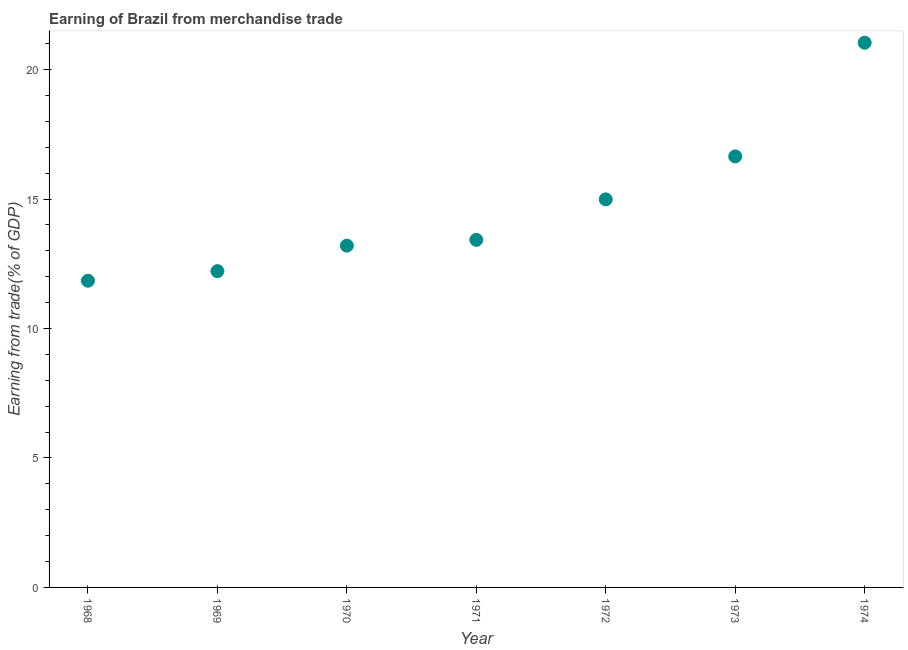What is the earning from merchandise trade in 1970?
Make the answer very short. 13.2. Across all years, what is the maximum earning from merchandise trade?
Your answer should be very brief. 21.04. Across all years, what is the minimum earning from merchandise trade?
Keep it short and to the point. 11.85. In which year was the earning from merchandise trade maximum?
Provide a short and direct response. 1974. In which year was the earning from merchandise trade minimum?
Your answer should be compact. 1968. What is the sum of the earning from merchandise trade?
Make the answer very short. 103.36. What is the difference between the earning from merchandise trade in 1970 and 1973?
Offer a terse response. -3.45. What is the average earning from merchandise trade per year?
Your answer should be very brief. 14.77. What is the median earning from merchandise trade?
Offer a terse response. 13.42. In how many years, is the earning from merchandise trade greater than 19 %?
Make the answer very short. 1. What is the ratio of the earning from merchandise trade in 1972 to that in 1973?
Your answer should be very brief. 0.9. Is the earning from merchandise trade in 1971 less than that in 1974?
Provide a succinct answer. Yes. Is the difference between the earning from merchandise trade in 1969 and 1973 greater than the difference between any two years?
Make the answer very short. No. What is the difference between the highest and the second highest earning from merchandise trade?
Your answer should be compact. 4.39. What is the difference between the highest and the lowest earning from merchandise trade?
Your response must be concise. 9.19. What is the title of the graph?
Make the answer very short. Earning of Brazil from merchandise trade. What is the label or title of the X-axis?
Ensure brevity in your answer.  Year. What is the label or title of the Y-axis?
Your answer should be compact. Earning from trade(% of GDP). What is the Earning from trade(% of GDP) in 1968?
Provide a short and direct response. 11.85. What is the Earning from trade(% of GDP) in 1969?
Your answer should be compact. 12.22. What is the Earning from trade(% of GDP) in 1970?
Provide a succinct answer. 13.2. What is the Earning from trade(% of GDP) in 1971?
Provide a succinct answer. 13.42. What is the Earning from trade(% of GDP) in 1972?
Keep it short and to the point. 14.99. What is the Earning from trade(% of GDP) in 1973?
Make the answer very short. 16.65. What is the Earning from trade(% of GDP) in 1974?
Your answer should be very brief. 21.04. What is the difference between the Earning from trade(% of GDP) in 1968 and 1969?
Provide a succinct answer. -0.37. What is the difference between the Earning from trade(% of GDP) in 1968 and 1970?
Your response must be concise. -1.36. What is the difference between the Earning from trade(% of GDP) in 1968 and 1971?
Offer a very short reply. -1.58. What is the difference between the Earning from trade(% of GDP) in 1968 and 1972?
Keep it short and to the point. -3.14. What is the difference between the Earning from trade(% of GDP) in 1968 and 1973?
Keep it short and to the point. -4.8. What is the difference between the Earning from trade(% of GDP) in 1968 and 1974?
Offer a very short reply. -9.19. What is the difference between the Earning from trade(% of GDP) in 1969 and 1970?
Ensure brevity in your answer.  -0.99. What is the difference between the Earning from trade(% of GDP) in 1969 and 1971?
Give a very brief answer. -1.21. What is the difference between the Earning from trade(% of GDP) in 1969 and 1972?
Offer a terse response. -2.77. What is the difference between the Earning from trade(% of GDP) in 1969 and 1973?
Your answer should be very brief. -4.43. What is the difference between the Earning from trade(% of GDP) in 1969 and 1974?
Your answer should be compact. -8.82. What is the difference between the Earning from trade(% of GDP) in 1970 and 1971?
Your answer should be very brief. -0.22. What is the difference between the Earning from trade(% of GDP) in 1970 and 1972?
Make the answer very short. -1.79. What is the difference between the Earning from trade(% of GDP) in 1970 and 1973?
Make the answer very short. -3.45. What is the difference between the Earning from trade(% of GDP) in 1970 and 1974?
Provide a short and direct response. -7.84. What is the difference between the Earning from trade(% of GDP) in 1971 and 1972?
Your answer should be compact. -1.56. What is the difference between the Earning from trade(% of GDP) in 1971 and 1973?
Provide a succinct answer. -3.22. What is the difference between the Earning from trade(% of GDP) in 1971 and 1974?
Offer a terse response. -7.61. What is the difference between the Earning from trade(% of GDP) in 1972 and 1973?
Keep it short and to the point. -1.66. What is the difference between the Earning from trade(% of GDP) in 1972 and 1974?
Ensure brevity in your answer.  -6.05. What is the difference between the Earning from trade(% of GDP) in 1973 and 1974?
Provide a short and direct response. -4.39. What is the ratio of the Earning from trade(% of GDP) in 1968 to that in 1970?
Keep it short and to the point. 0.9. What is the ratio of the Earning from trade(% of GDP) in 1968 to that in 1971?
Your response must be concise. 0.88. What is the ratio of the Earning from trade(% of GDP) in 1968 to that in 1972?
Provide a short and direct response. 0.79. What is the ratio of the Earning from trade(% of GDP) in 1968 to that in 1973?
Give a very brief answer. 0.71. What is the ratio of the Earning from trade(% of GDP) in 1968 to that in 1974?
Make the answer very short. 0.56. What is the ratio of the Earning from trade(% of GDP) in 1969 to that in 1970?
Your answer should be compact. 0.93. What is the ratio of the Earning from trade(% of GDP) in 1969 to that in 1971?
Ensure brevity in your answer.  0.91. What is the ratio of the Earning from trade(% of GDP) in 1969 to that in 1972?
Your answer should be very brief. 0.81. What is the ratio of the Earning from trade(% of GDP) in 1969 to that in 1973?
Provide a short and direct response. 0.73. What is the ratio of the Earning from trade(% of GDP) in 1969 to that in 1974?
Keep it short and to the point. 0.58. What is the ratio of the Earning from trade(% of GDP) in 1970 to that in 1972?
Your answer should be compact. 0.88. What is the ratio of the Earning from trade(% of GDP) in 1970 to that in 1973?
Offer a terse response. 0.79. What is the ratio of the Earning from trade(% of GDP) in 1970 to that in 1974?
Provide a succinct answer. 0.63. What is the ratio of the Earning from trade(% of GDP) in 1971 to that in 1972?
Your answer should be compact. 0.9. What is the ratio of the Earning from trade(% of GDP) in 1971 to that in 1973?
Keep it short and to the point. 0.81. What is the ratio of the Earning from trade(% of GDP) in 1971 to that in 1974?
Make the answer very short. 0.64. What is the ratio of the Earning from trade(% of GDP) in 1972 to that in 1974?
Make the answer very short. 0.71. What is the ratio of the Earning from trade(% of GDP) in 1973 to that in 1974?
Your answer should be very brief. 0.79. 